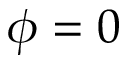Convert formula to latex. <formula><loc_0><loc_0><loc_500><loc_500>\phi = 0</formula> 